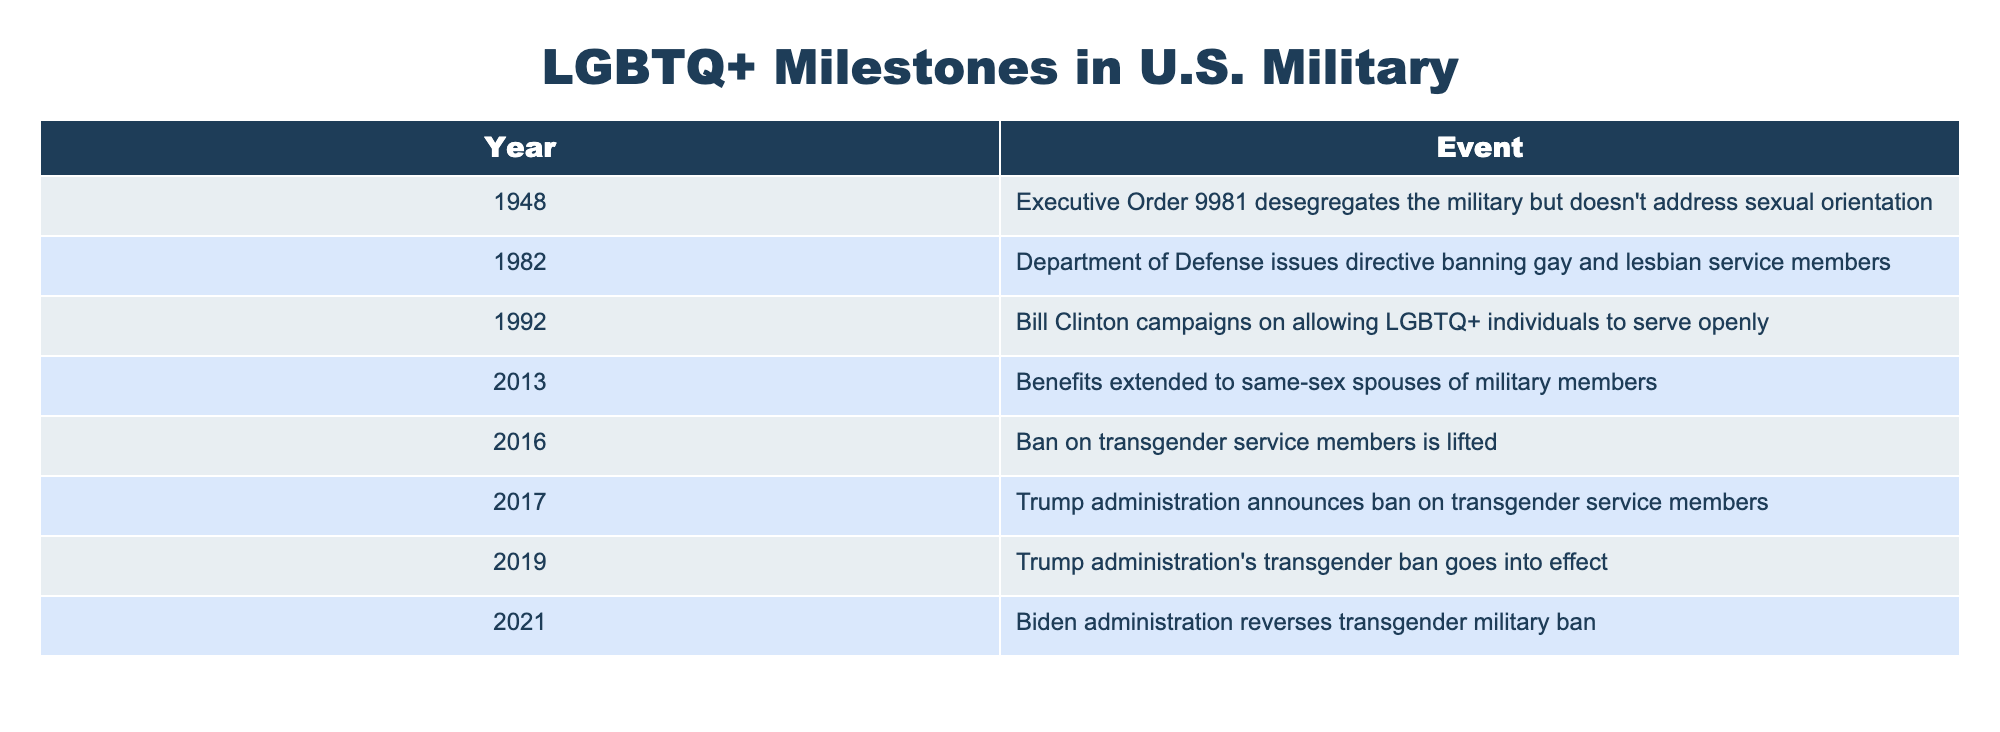What year did the Department of Defense issue the directive banning gay and lesbian service members? The table lists the events chronologically by year. The row that mentions the Department of Defense issuing a directive banning gay and lesbian service members states 1982 as the corresponding year.
Answer: 1982 In what year was the ban on transgender service members lifted? According to the table, the event that marks the lifting of the ban on transgender service members is noted in the year 2016.
Answer: 2016 What significant action did the Biden administration take regarding transgender service members? The table indicates that the Biden administration reversed the transgender military ban, which is a significant development noted in the year 2021.
Answer: Reversed the transgender military ban How many events in the table occurred after the year 2000? The events occurring after the year 2000 listed in the table include four specific years: 2013, 2016, 2017, 2019, and 2021. Counting these events gives us a total of five.
Answer: 5 Was the military integrated for all sexual orientations by the time Executive Order 9981 was enacted? The table shows that Executive Order 9981 was enacted in 1948 but specifically mentions that it did not address sexual orientation, suggesting that not all orientations were integrated at that time.
Answer: No How many years separated the banning of gay and lesbian service members and the lifting of the ban on transgender service members? The ban on gay and lesbian service members was imposed in 1982, while the ban on transgender service members was lifted in 2016. The difference in years is 2016 - 1982 = 34 years.
Answer: 34 years Did the Trump administration's transgender ban go into effect before or after Biden's administration reversed it? The table records that the Trump administration's transgender ban went into effect in 2019, while the reversal by Biden's administration occurred in 2021. Since 2019 comes before 2021, the ban went into effect before the reversal.
Answer: Before What is the chronological order of the events listed in the table, starting from the earliest to the latest? Referring to the table, the chronological order starting from the earliest event to the latest is: 1948 (Executive Order 9981), 1982 (Department of Defense directive), 1992 (Clinton campaign), 2013 (same-sex spouse benefits), 2016 (lifting transgender ban), 2017 (Trump ban announcement), 2019 (ban goes into effect), 2021 (Biden reverses ban). This step-by-step extraction shows the progression of events over time.
Answer: 1948, 1982, 1992, 2013, 2016, 2017, 2019, 2021 How many total events related to LGBTQ+ milestones in the U.S. military are documented in the table? The table lists a total of eight distinct events, which can be counted directly from the rows provided. This count gives a complete picture of the documented milestones.
Answer: 8 